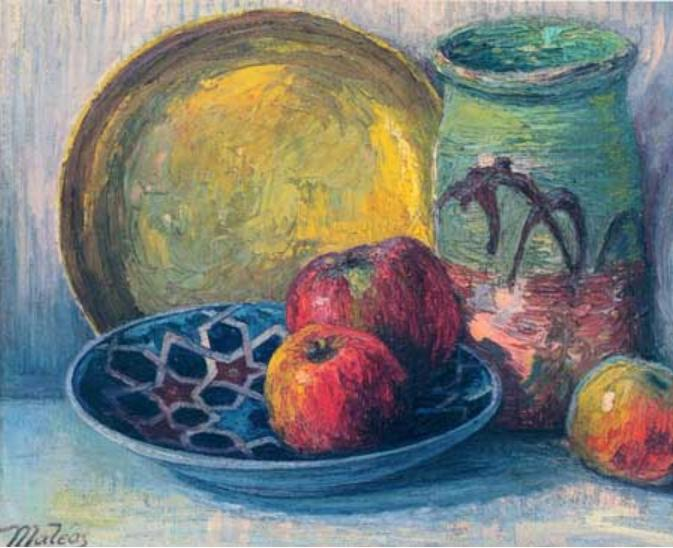Imagine the objects in the painting come to life. What adventure might they go on? In a whimsical twist, as the clock struck midnight, the objects in Mateo's painting began to stir. The red apples, with a gentle roll, tumbled out of the bowl, waking up the green vase with a rustle.

'Where shall we wander tonight?' the vase pondered, its painted vines growing slightly more vibrant.

The apples, always vibrant and full of curiosity, suggested an adventure to the Enchanted Orchard beyond the kitchen walls. The blue bowl, shaking off its static existence, sprang up with a will to accompany its companions.

Together, they nudged the window open and tumbled onto the moonlit garden path. As they rolled and bounced, they discovered the magic of the night—glowing fireflies that danced around them, whispering secrets of the ancient trees. They navigated through tall grass, the yellow plate lighting up their path like a little sun.

At the Enchanted Orchard, they found trees that sang melodies as the wind brushed through their leaves and fruits that glowed in the dark, giving off a faint, sweet aroma. They danced and played, swaying to the rhythm of the Orchard's lullaby until dawn began to break.

With the first light of morning, they hurried back to the cottage and back to their places in the painting, just before Mateo woke up. Although the scene looked just as it did the day before, it now held within it the essence of a magical adventure, ready to whisper its tale to anyone who might look closely enough. 